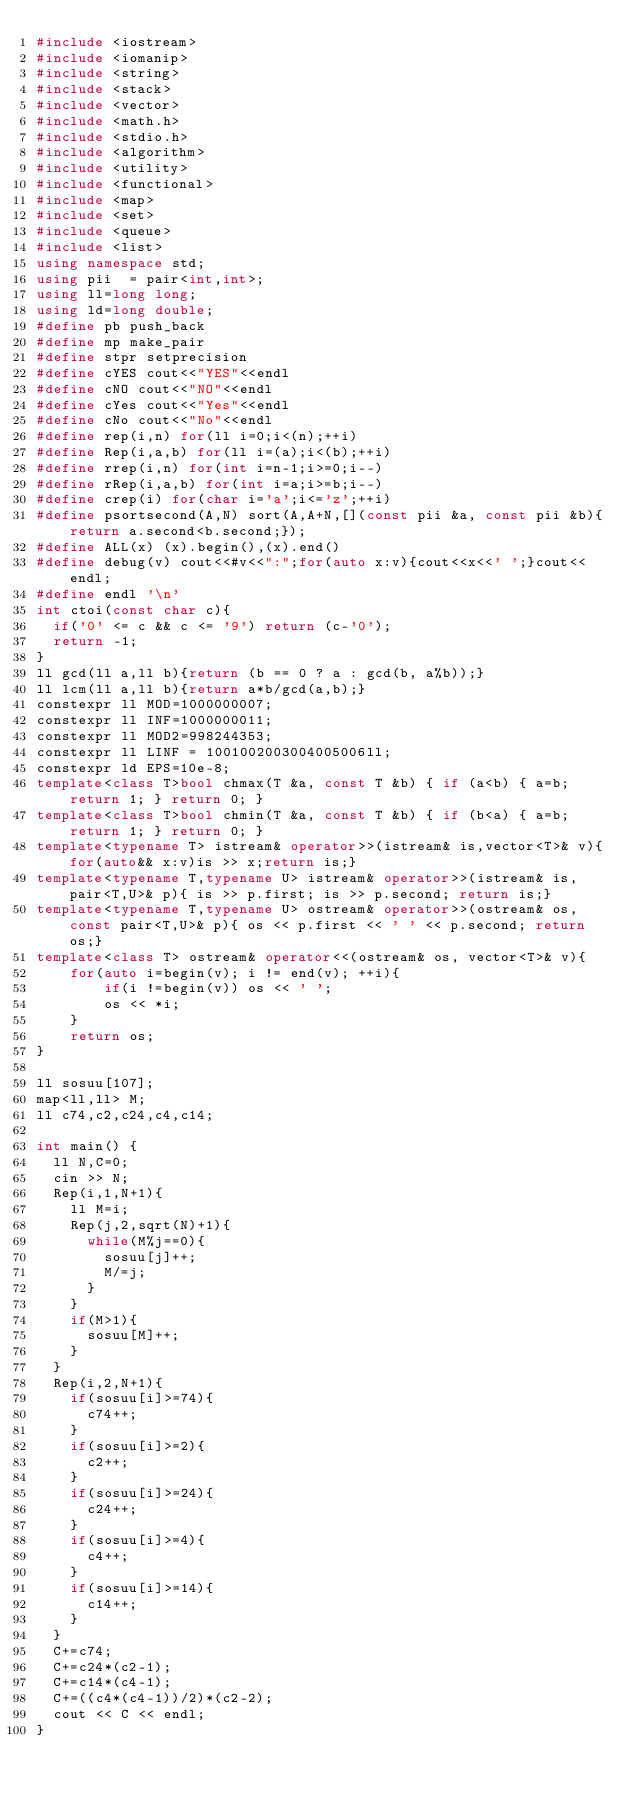<code> <loc_0><loc_0><loc_500><loc_500><_C++_>#include <iostream>
#include <iomanip>
#include <string>
#include <stack>
#include <vector>
#include <math.h>
#include <stdio.h>
#include <algorithm>
#include <utility>
#include <functional>
#include <map>
#include <set>
#include <queue>
#include <list>
using namespace std;
using pii  = pair<int,int>;
using ll=long long;
using ld=long double;
#define pb push_back
#define mp make_pair
#define stpr setprecision
#define cYES cout<<"YES"<<endl
#define cNO cout<<"NO"<<endl
#define cYes cout<<"Yes"<<endl
#define cNo cout<<"No"<<endl
#define rep(i,n) for(ll i=0;i<(n);++i)
#define Rep(i,a,b) for(ll i=(a);i<(b);++i)
#define rrep(i,n) for(int i=n-1;i>=0;i--)
#define rRep(i,a,b) for(int i=a;i>=b;i--)
#define crep(i) for(char i='a';i<='z';++i)
#define psortsecond(A,N) sort(A,A+N,[](const pii &a, const pii &b){return a.second<b.second;});
#define ALL(x) (x).begin(),(x).end()
#define debug(v) cout<<#v<<":";for(auto x:v){cout<<x<<' ';}cout<<endl;
#define endl '\n'
int ctoi(const char c){
  if('0' <= c && c <= '9') return (c-'0');
  return -1;
}
ll gcd(ll a,ll b){return (b == 0 ? a : gcd(b, a%b));}
ll lcm(ll a,ll b){return a*b/gcd(a,b);}
constexpr ll MOD=1000000007;
constexpr ll INF=1000000011;
constexpr ll MOD2=998244353;
constexpr ll LINF = 1001002003004005006ll;
constexpr ld EPS=10e-8;
template<class T>bool chmax(T &a, const T &b) { if (a<b) { a=b; return 1; } return 0; }
template<class T>bool chmin(T &a, const T &b) { if (b<a) { a=b; return 1; } return 0; }
template<typename T> istream& operator>>(istream& is,vector<T>& v){for(auto&& x:v)is >> x;return is;}
template<typename T,typename U> istream& operator>>(istream& is, pair<T,U>& p){ is >> p.first; is >> p.second; return is;}
template<typename T,typename U> ostream& operator>>(ostream& os, const pair<T,U>& p){ os << p.first << ' ' << p.second; return os;}
template<class T> ostream& operator<<(ostream& os, vector<T>& v){
    for(auto i=begin(v); i != end(v); ++i){
        if(i !=begin(v)) os << ' ';
        os << *i;
    }
    return os;
}

ll sosuu[107];
map<ll,ll> M;
ll c74,c2,c24,c4,c14;

int main() {
  ll N,C=0;
  cin >> N;
  Rep(i,1,N+1){
    ll M=i;
    Rep(j,2,sqrt(N)+1){
      while(M%j==0){
        sosuu[j]++;
        M/=j;
      }
    }
    if(M>1){
      sosuu[M]++;
    }
  }
  Rep(i,2,N+1){
    if(sosuu[i]>=74){
      c74++;
    }
    if(sosuu[i]>=2){
      c2++;
    }
    if(sosuu[i]>=24){
      c24++;
    }
    if(sosuu[i]>=4){
      c4++;
    }
    if(sosuu[i]>=14){
      c14++;
    }
  }
  C+=c74;
  C+=c24*(c2-1);
  C+=c14*(c4-1);
  C+=((c4*(c4-1))/2)*(c2-2);
  cout << C << endl;
}</code> 